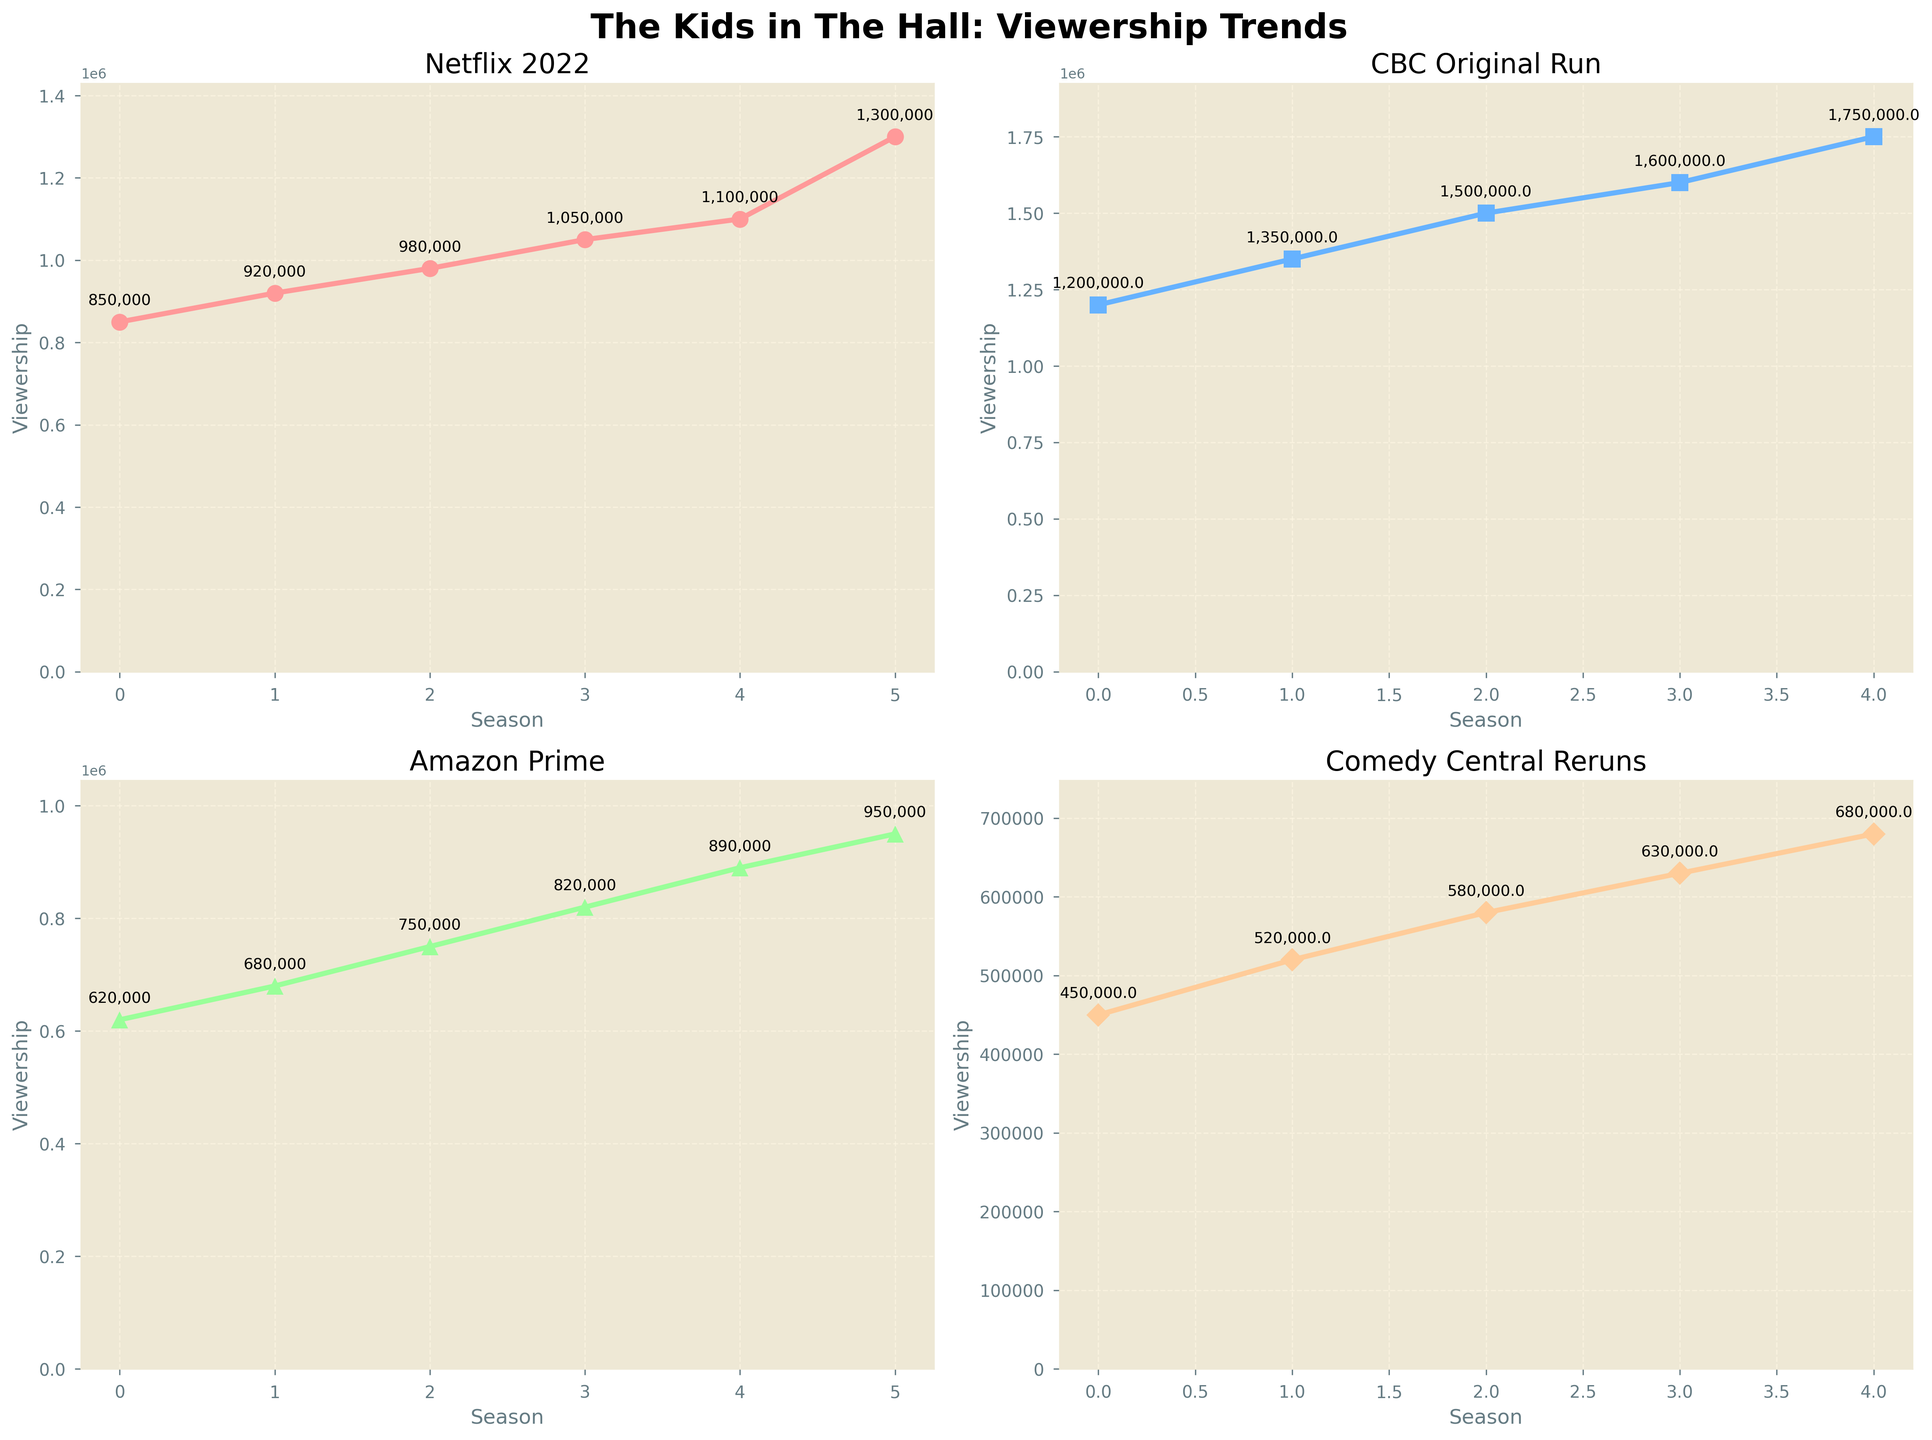Which platform had the highest viewership for Season 3? Looking at Season 3 across all subplots, the highest viewership is on the CBC Original Run plot with 1,500,000 viewers.
Answer: CBC Original Run How much more viewership did the 2022 Revival on Netflix gain compared to Season 1 on the same platform? The Netflix 2022 Revival had 1,300,000 viewers and Season 1 had 850,000 viewers. The difference is 1,300,000 - 850,000 = 450,000 viewers.
Answer: 450,000 In which season did Amazon Prime see its highest viewership? By examining the Amazon Prime subplot, the highest viewership is in the 2022 Revival with 950,000 viewers.
Answer: 2022 Revival Compare the viewership between the Comedy Central Reruns and Netflix for Season 4. Which has more viewership and by how much? Comedy Central Reruns for Season 4 had 630,000 viewers, while Netflix had 1,050,000 viewers. The difference is 1,050,000 - 630,000 = 420,000 viewers.
Answer: Netflix by 420,000 What is the total viewership across all platforms for Season 2? Summing up the viewership for Season 2: Netflix (920,000) + CBC Original Run (1,350,000) + Amazon Prime (680,000) + Comedy Central Reruns (520,000) = 3,470,000 viewers.
Answer: 3,470,000 How does the trend in viewership for CBC Original Run compare to that of Comedy Central Reruns over the first five seasons? The viewership for CBC Original Run consistently increases from Season 1 to Season 5 (1,200,000 to 1,750,000), while Comedy Central Reruns also show an increasing trend but with lower numbers (450,000 to 680,000). CBC Original Run increases more sharply.
Answer: CBC Original Run increases more sharply What is the average viewership for Seasons 1 through 5 on Amazon Prime? The viewership for Amazon Prime over these seasons is 620,000, 680,000, 750,000, 820,000, and 890,000. The sum is 3,760,000, and the average is 3,760,000 / 5 = 752,000 viewers.
Answer: 752,000 Which platform saw the least growth in viewership from Season 1 to Season 4? By comparing the growth, Netflix increased from 850,000 to 1,050,000 (200,000 growth), CBC Original Run from 1,200,000 to 1,600,000 (400,000 growth), Amazon Prime from 620,000 to 820,000 (200,000 growth), and Comedy Central Reruns from 450,000 to 630,000 (180,000 growth). Comedy Central Reruns saw the least growth.
Answer: Comedy Central Reruns 